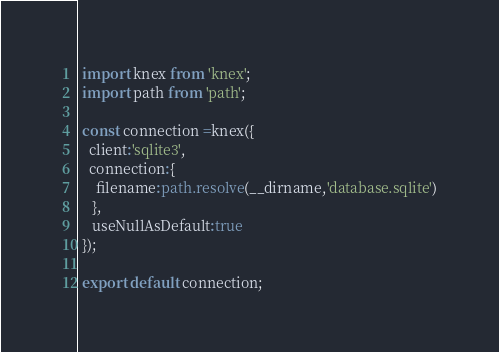Convert code to text. <code><loc_0><loc_0><loc_500><loc_500><_TypeScript_> import knex from 'knex';
 import path from 'path';

 const connection =knex({
   client:'sqlite3',
   connection:{
     filename:path.resolve(__dirname,'database.sqlite')
    },
    useNullAsDefault:true
 });

 export default connection; </code> 